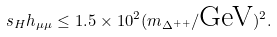Convert formula to latex. <formula><loc_0><loc_0><loc_500><loc_500>s _ { H } h _ { \mu \mu } \leq 1 . 5 \times 1 0 ^ { 2 } ( m _ { \Delta ^ { + + } } / \text {GeV} ) ^ { 2 } .</formula> 